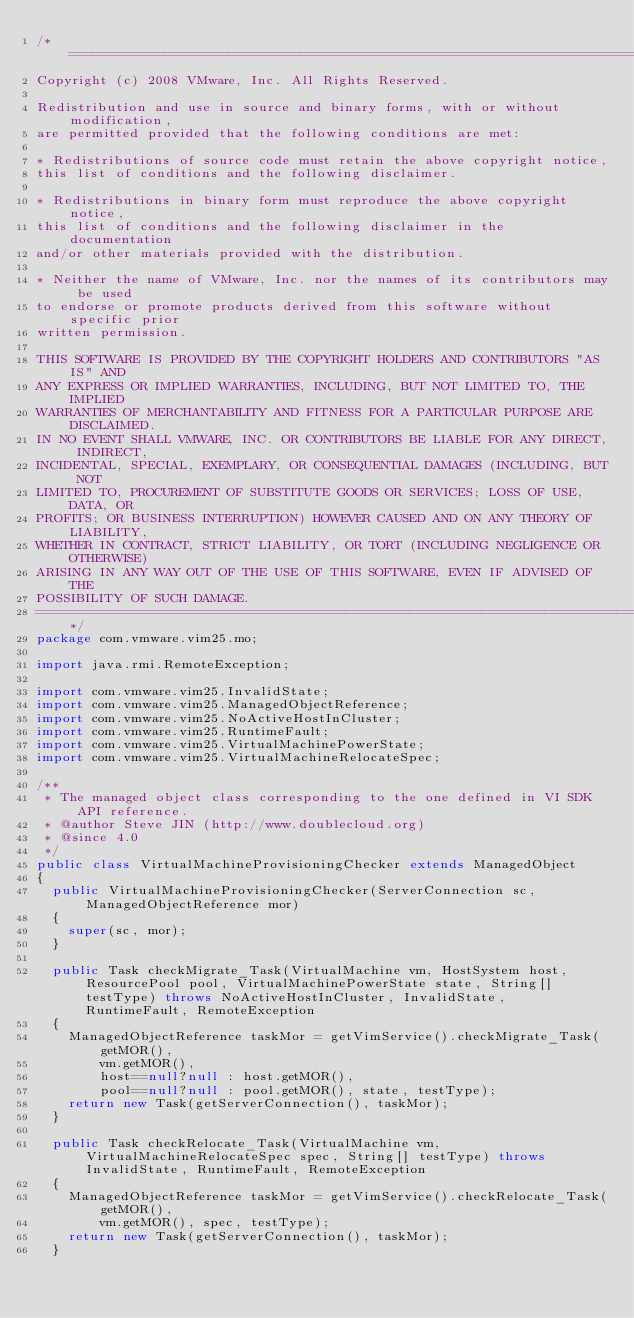<code> <loc_0><loc_0><loc_500><loc_500><_Java_>/*================================================================================
Copyright (c) 2008 VMware, Inc. All Rights Reserved.

Redistribution and use in source and binary forms, with or without modification, 
are permitted provided that the following conditions are met:

* Redistributions of source code must retain the above copyright notice, 
this list of conditions and the following disclaimer.

* Redistributions in binary form must reproduce the above copyright notice, 
this list of conditions and the following disclaimer in the documentation 
and/or other materials provided with the distribution.

* Neither the name of VMware, Inc. nor the names of its contributors may be used
to endorse or promote products derived from this software without specific prior 
written permission.

THIS SOFTWARE IS PROVIDED BY THE COPYRIGHT HOLDERS AND CONTRIBUTORS "AS IS" AND 
ANY EXPRESS OR IMPLIED WARRANTIES, INCLUDING, BUT NOT LIMITED TO, THE IMPLIED 
WARRANTIES OF MERCHANTABILITY AND FITNESS FOR A PARTICULAR PURPOSE ARE DISCLAIMED. 
IN NO EVENT SHALL VMWARE, INC. OR CONTRIBUTORS BE LIABLE FOR ANY DIRECT, INDIRECT, 
INCIDENTAL, SPECIAL, EXEMPLARY, OR CONSEQUENTIAL DAMAGES (INCLUDING, BUT NOT 
LIMITED TO, PROCUREMENT OF SUBSTITUTE GOODS OR SERVICES; LOSS OF USE, DATA, OR 
PROFITS; OR BUSINESS INTERRUPTION) HOWEVER CAUSED AND ON ANY THEORY OF LIABILITY, 
WHETHER IN CONTRACT, STRICT LIABILITY, OR TORT (INCLUDING NEGLIGENCE OR OTHERWISE) 
ARISING IN ANY WAY OUT OF THE USE OF THIS SOFTWARE, EVEN IF ADVISED OF THE 
POSSIBILITY OF SUCH DAMAGE.
================================================================================*/
package com.vmware.vim25.mo;

import java.rmi.RemoteException;

import com.vmware.vim25.InvalidState;
import com.vmware.vim25.ManagedObjectReference;
import com.vmware.vim25.NoActiveHostInCluster;
import com.vmware.vim25.RuntimeFault;
import com.vmware.vim25.VirtualMachinePowerState;
import com.vmware.vim25.VirtualMachineRelocateSpec;

/**
 * The managed object class corresponding to the one defined in VI SDK API reference.
 * @author Steve JIN (http://www.doublecloud.org)
 * @since 4.0
 */
public class VirtualMachineProvisioningChecker extends ManagedObject 
{
  public VirtualMachineProvisioningChecker(ServerConnection sc, ManagedObjectReference mor) 
  {
    super(sc, mor);
  }
  
  public Task checkMigrate_Task(VirtualMachine vm, HostSystem host, ResourcePool pool, VirtualMachinePowerState state, String[] testType) throws NoActiveHostInCluster, InvalidState, RuntimeFault, RemoteException
  {
    ManagedObjectReference taskMor = getVimService().checkMigrate_Task(getMOR(), 
        vm.getMOR(), 
        host==null?null : host.getMOR(), 
        pool==null?null : pool.getMOR(), state, testType);
    return new Task(getServerConnection(), taskMor);
  }
  
  public Task checkRelocate_Task(VirtualMachine vm, VirtualMachineRelocateSpec spec, String[] testType) throws InvalidState, RuntimeFault, RemoteException
  {
    ManagedObjectReference taskMor = getVimService().checkRelocate_Task(getMOR(), 
        vm.getMOR(), spec, testType);
    return new Task(getServerConnection(), taskMor);
  }
  </code> 